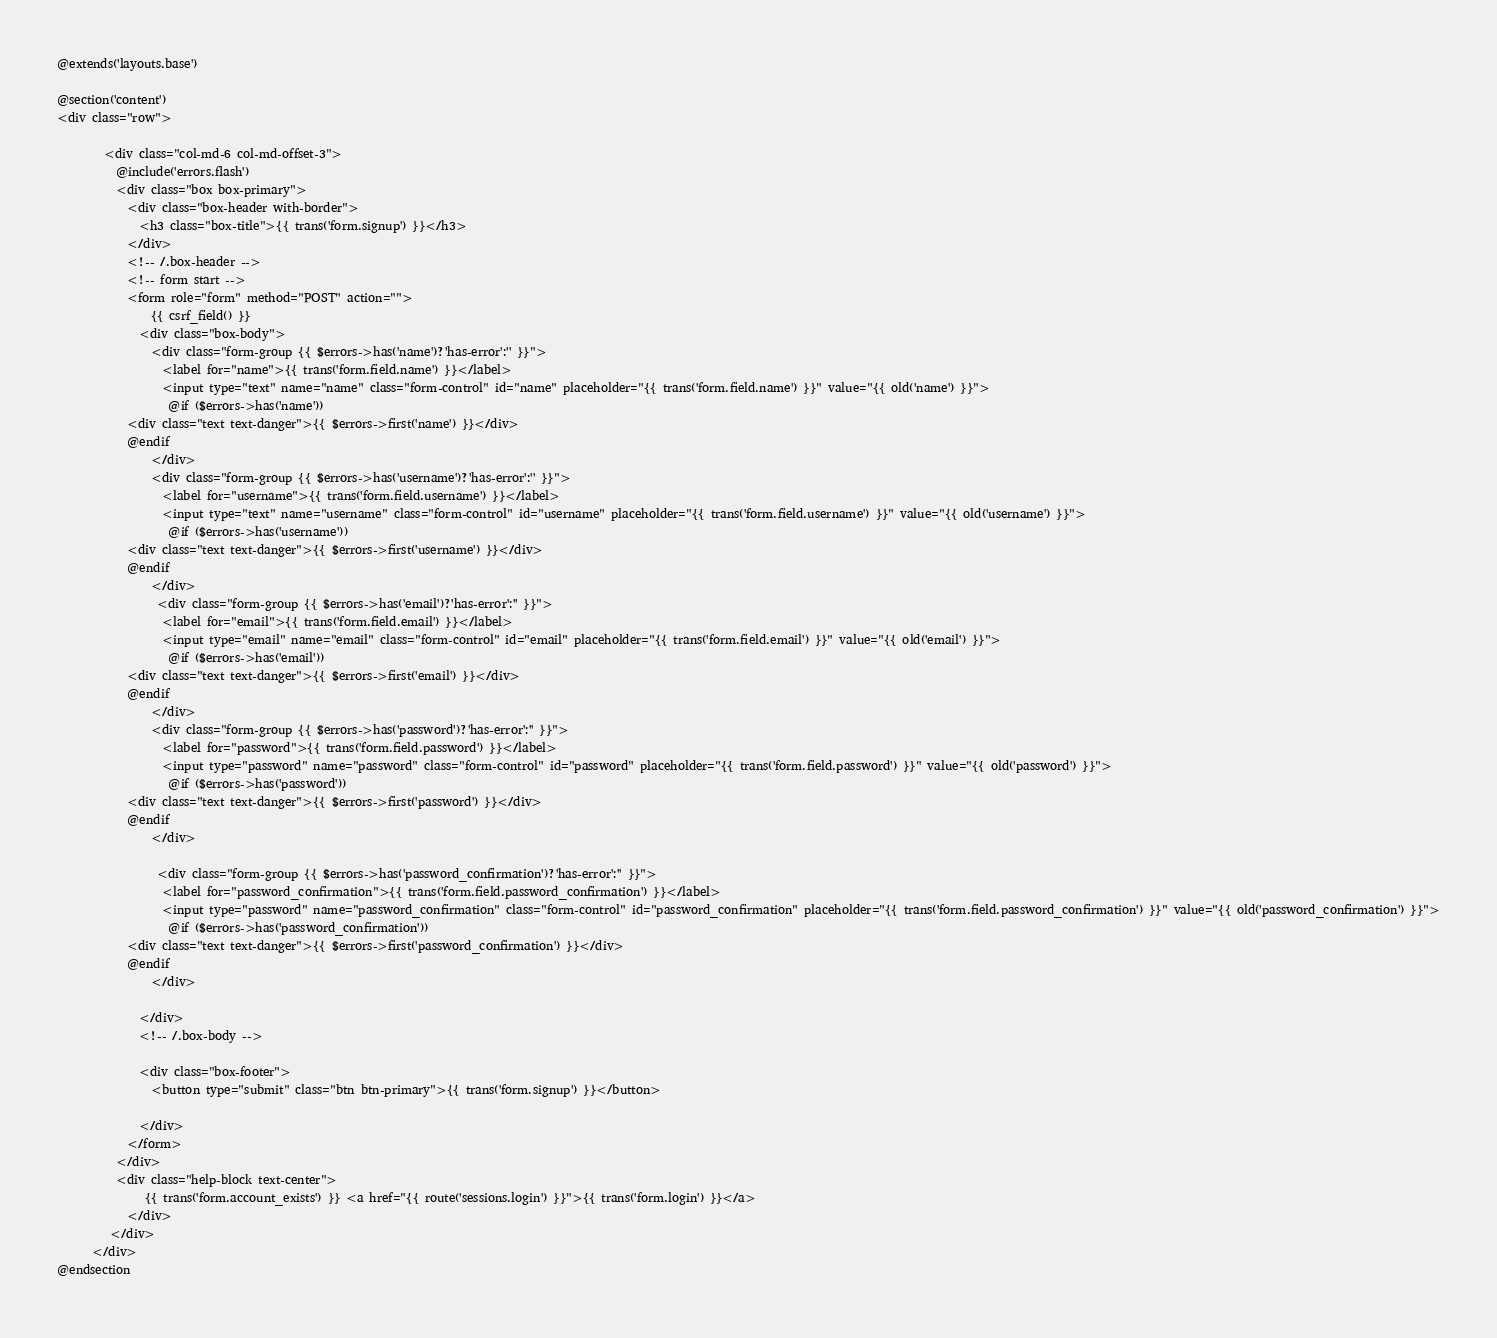Convert code to text. <code><loc_0><loc_0><loc_500><loc_500><_PHP_>@extends('layouts.base')

@section('content')
<div class="row">
       
        <div class="col-md-6 col-md-offset-3">
          @include('errors.flash')
          <div class="box box-primary">
            <div class="box-header with-border">
              <h3 class="box-title">{{ trans('form.signup') }}</h3>
            </div>
            <!-- /.box-header -->
            <!-- form start -->
            <form role="form" method="POST" action="">
            	{{ csrf_field() }}
              <div class="box-body">
                <div class="form-group {{ $errors->has('name')?'has-error':'' }}">
                  <label for="name">{{ trans('form.field.name') }}</label>
                  <input type="text" name="name" class="form-control" id="name" placeholder="{{ trans('form.field.name') }}" value="{{ old('name') }}">
                   @if ($errors->has('name'))
            <div class="text text-danger">{{ $errors->first('name') }}</div>
            @endif
                </div>
                <div class="form-group {{ $errors->has('username')?'has-error':'' }}">
                  <label for="username">{{ trans('form.field.username') }}</label>
                  <input type="text" name="username" class="form-control" id="username" placeholder="{{ trans('form.field.username') }}" value="{{ old('username') }}">
                   @if ($errors->has('username'))
            <div class="text text-danger">{{ $errors->first('username') }}</div>
            @endif
                </div>
                 <div class="form-group {{ $errors->has('email')?'has-error':'' }}">
                  <label for="email">{{ trans('form.field.email') }}</label>
                  <input type="email" name="email" class="form-control" id="email" placeholder="{{ trans('form.field.email') }}" value="{{ old('email') }}">
                   @if ($errors->has('email'))
            <div class="text text-danger">{{ $errors->first('email') }}</div>
            @endif
                </div>
                <div class="form-group {{ $errors->has('password')?'has-error':'' }}">
                  <label for="password">{{ trans('form.field.password') }}</label>
                  <input type="password" name="password" class="form-control" id="password" placeholder="{{ trans('form.field.password') }}" value="{{ old('password') }}">
                   @if ($errors->has('password'))
            <div class="text text-danger">{{ $errors->first('password') }}</div>
            @endif
                </div>

                 <div class="form-group {{ $errors->has('password_confirmation')?'has-error':'' }}">
                  <label for="password_confirmation">{{ trans('form.field.password_confirmation') }}</label>
                  <input type="password" name="password_confirmation" class="form-control" id="password_confirmation" placeholder="{{ trans('form.field.password_confirmation') }}" value="{{ old('password_confirmation') }}">
                   @if ($errors->has('password_confirmation'))
            <div class="text text-danger">{{ $errors->first('password_confirmation') }}</div>
            @endif
                </div>
              
              </div>
              <!-- /.box-body -->

              <div class="box-footer">
                <button type="submit" class="btn btn-primary">{{ trans('form.signup') }}</button>
                
              </div>
            </form>
          </div>
          <div class="help-block text-center">
			   {{ trans('form.account_exists') }} <a href="{{ route('sessions.login') }}">{{ trans('form.login') }}</a>
			</div>
         </div>
      </div>
@endsection</code> 